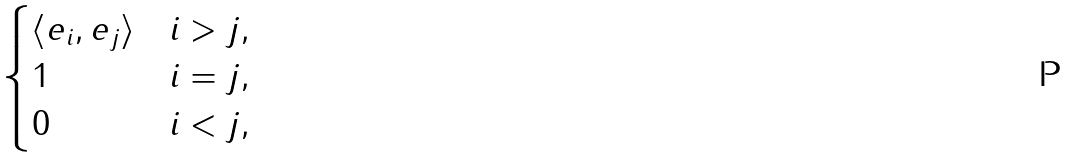<formula> <loc_0><loc_0><loc_500><loc_500>\begin{cases} \langle e _ { i } , e _ { j } \rangle & i > j , \\ 1 & i = j , \\ 0 & i < j , \end{cases}</formula> 